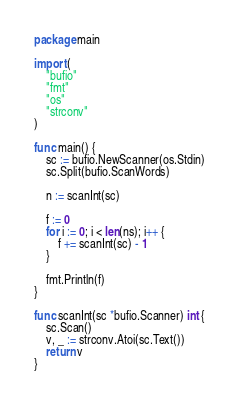Convert code to text. <code><loc_0><loc_0><loc_500><loc_500><_Go_>package main

import (
	"bufio"
	"fmt"
	"os"
	"strconv"
)

func main() {
	sc := bufio.NewScanner(os.Stdin)
	sc.Split(bufio.ScanWords)

	n := scanInt(sc)

	f := 0
	for i := 0; i < len(ns); i++ {
		f += scanInt(sc) - 1
	}

	fmt.Println(f)
}

func scanInt(sc *bufio.Scanner) int {
	sc.Scan()
	v, _ := strconv.Atoi(sc.Text())
	return v
}
</code> 